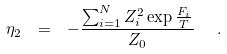Convert formula to latex. <formula><loc_0><loc_0><loc_500><loc_500>\eta _ { 2 } \ = \ - \frac { \sum _ { i = 1 } ^ { N } Z _ { i } ^ { 2 } \exp { \frac { F _ { i } } { T } } } { Z _ { 0 } } \ \ .</formula> 